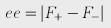<formula> <loc_0><loc_0><loc_500><loc_500>e e = | F _ { + } - F _ { - } |</formula> 